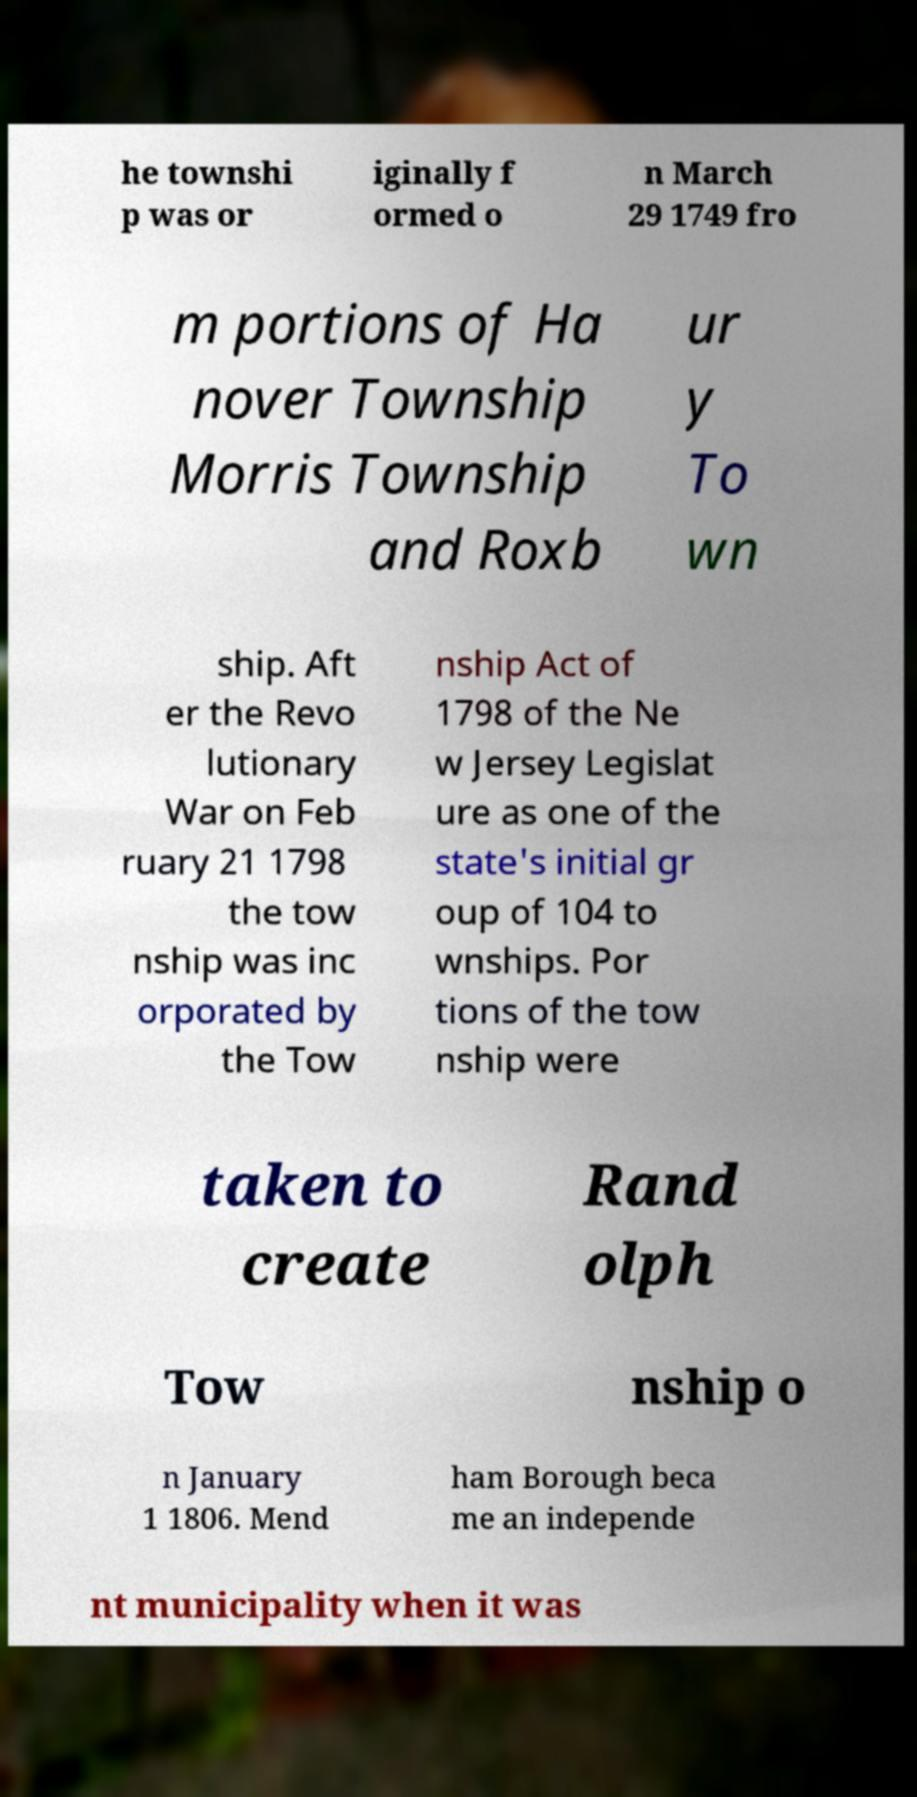For documentation purposes, I need the text within this image transcribed. Could you provide that? he townshi p was or iginally f ormed o n March 29 1749 fro m portions of Ha nover Township Morris Township and Roxb ur y To wn ship. Aft er the Revo lutionary War on Feb ruary 21 1798 the tow nship was inc orporated by the Tow nship Act of 1798 of the Ne w Jersey Legislat ure as one of the state's initial gr oup of 104 to wnships. Por tions of the tow nship were taken to create Rand olph Tow nship o n January 1 1806. Mend ham Borough beca me an independe nt municipality when it was 